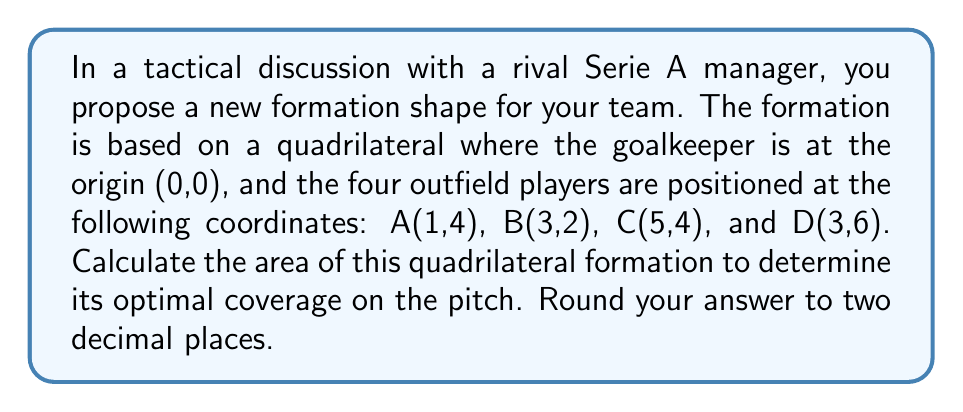Help me with this question. To solve this problem, we'll use the Shoelace formula (also known as the surveyor's formula) to calculate the area of the quadrilateral. The steps are as follows:

1) The Shoelace formula for a quadrilateral with vertices $(x_1, y_1)$, $(x_2, y_2)$, $(x_3, y_3)$, and $(x_4, y_4)$ is:

   $$Area = \frac{1}{2}|x_1y_2 + x_2y_3 + x_3y_4 + x_4y_1 - y_1x_2 - y_2x_3 - y_3x_4 - y_4x_1|$$

2) We have the following coordinates:
   A(1,4), B(3,2), C(5,4), D(3,6)

3) Let's substitute these into the formula:

   $$Area = \frac{1}{2}|(1)(2) + (3)(4) + (5)(6) + (3)(4) - (4)(3) - (2)(5) - (4)(3) - (6)(1)|$$

4) Now let's calculate:

   $$Area = \frac{1}{2}|2 + 12 + 30 + 12 - 12 - 10 - 12 - 6|$$

5) Simplify inside the absolute value signs:

   $$Area = \frac{1}{2}|16|$$

6) Calculate:

   $$Area = \frac{1}{2}(16) = 8$$

Therefore, the area of the quadrilateral formation is 8 square units.

[asy]
unitsize(1cm);
dot((0,0));
dot((1,4));
dot((3,2));
dot((5,4));
dot((3,6));
draw((0,0)--(1,4)--(3,2)--(5,4)--(3,6)--cycle);
label("GK", (0,0), SW);
label("A", (1,4), NW);
label("B", (3,2), SE);
label("C", (5,4), NE);
label("D", (3,6), N);
[/asy]
Answer: 8.00 square units 